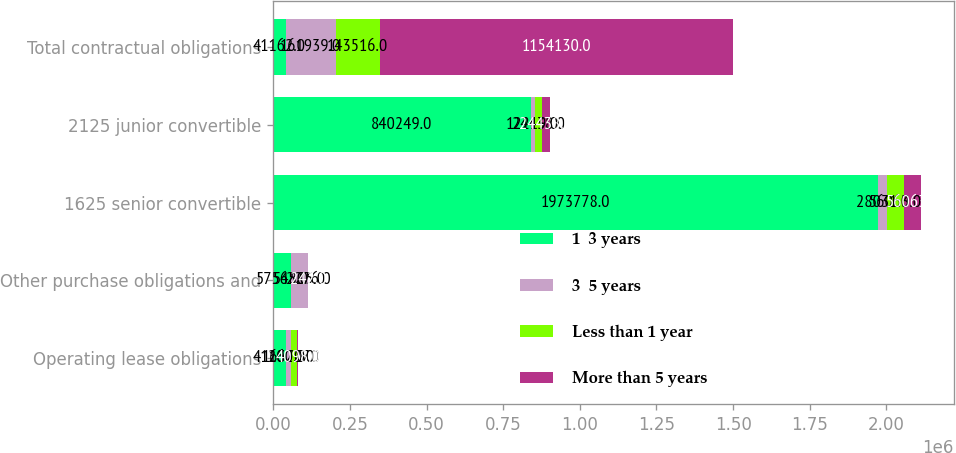Convert chart to OTSL. <chart><loc_0><loc_0><loc_500><loc_500><stacked_bar_chart><ecel><fcel>Operating lease obligations<fcel>Other purchase obligations and<fcel>1625 senior convertible<fcel>2125 junior convertible<fcel>Total contractual obligations<nl><fcel>1  3 years<fcel>41162<fcel>57565<fcel>1.97378e+06<fcel>840249<fcel>41162<nl><fcel>3  5 years<fcel>16370<fcel>54805<fcel>28031<fcel>12219<fcel>161939<nl><fcel>Less than 1 year<fcel>20027<fcel>2276<fcel>56063<fcel>24438<fcel>143516<nl><fcel>More than 5 years<fcel>4098<fcel>242<fcel>56063<fcel>24438<fcel>1.15413e+06<nl></chart> 